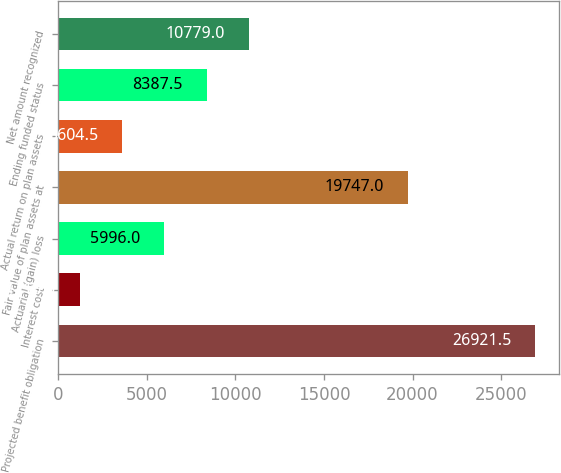Convert chart. <chart><loc_0><loc_0><loc_500><loc_500><bar_chart><fcel>Projected benefit obligation<fcel>Interest cost<fcel>Actuarial (gain) loss<fcel>Fair value of plan assets at<fcel>Actual return on plan assets<fcel>Ending funded status<fcel>Net amount recognized<nl><fcel>26921.5<fcel>1213<fcel>5996<fcel>19747<fcel>3604.5<fcel>8387.5<fcel>10779<nl></chart> 